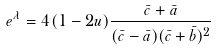<formula> <loc_0><loc_0><loc_500><loc_500>e ^ { \lambda } = 4 ( 1 - 2 u ) \frac { \bar { c } + \bar { a } } { ( \bar { c } - \bar { a } ) ( \bar { c } + \bar { b } ) ^ { 2 } }</formula> 